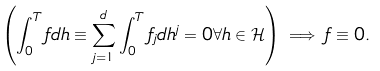Convert formula to latex. <formula><loc_0><loc_0><loc_500><loc_500>\left ( \int _ { 0 } ^ { T } f d h \equiv \sum _ { j = 1 } ^ { d } \int _ { 0 } ^ { T } f _ { j } d h ^ { j } = 0 \forall h \in \mathcal { H } \right ) \implies f \equiv 0 .</formula> 